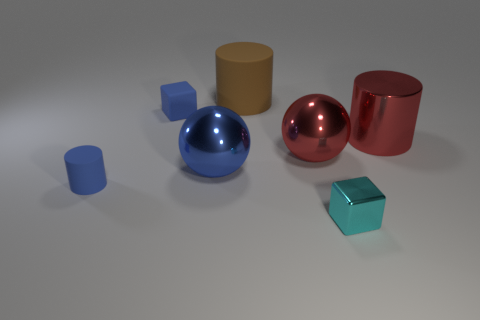How many other things are made of the same material as the red cylinder?
Make the answer very short. 3. There is a cube that is right of the big brown rubber cylinder; how many matte blocks are on the right side of it?
Your answer should be very brief. 0. Is there another cyan thing of the same shape as the big matte object?
Give a very brief answer. No. There is a tiny thing that is right of the brown matte cylinder; is it the same shape as the red object that is on the left side of the tiny cyan thing?
Keep it short and to the point. No. How many objects are either large red things or rubber cubes?
Offer a terse response. 3. What is the size of the metal thing that is the same shape as the large brown matte object?
Give a very brief answer. Large. Are there more large metallic things in front of the tiny cyan object than big metallic spheres?
Ensure brevity in your answer.  No. Does the small cylinder have the same material as the brown object?
Provide a short and direct response. Yes. How many things are either large objects left of the tiny cyan metallic cube or tiny objects that are in front of the red metal cylinder?
Your answer should be very brief. 5. The other big thing that is the same shape as the brown thing is what color?
Your answer should be very brief. Red. 